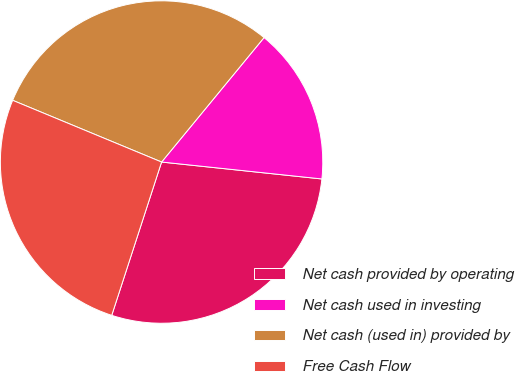Convert chart. <chart><loc_0><loc_0><loc_500><loc_500><pie_chart><fcel>Net cash provided by operating<fcel>Net cash used in investing<fcel>Net cash (used in) provided by<fcel>Free Cash Flow<nl><fcel>28.33%<fcel>15.71%<fcel>29.71%<fcel>26.25%<nl></chart> 